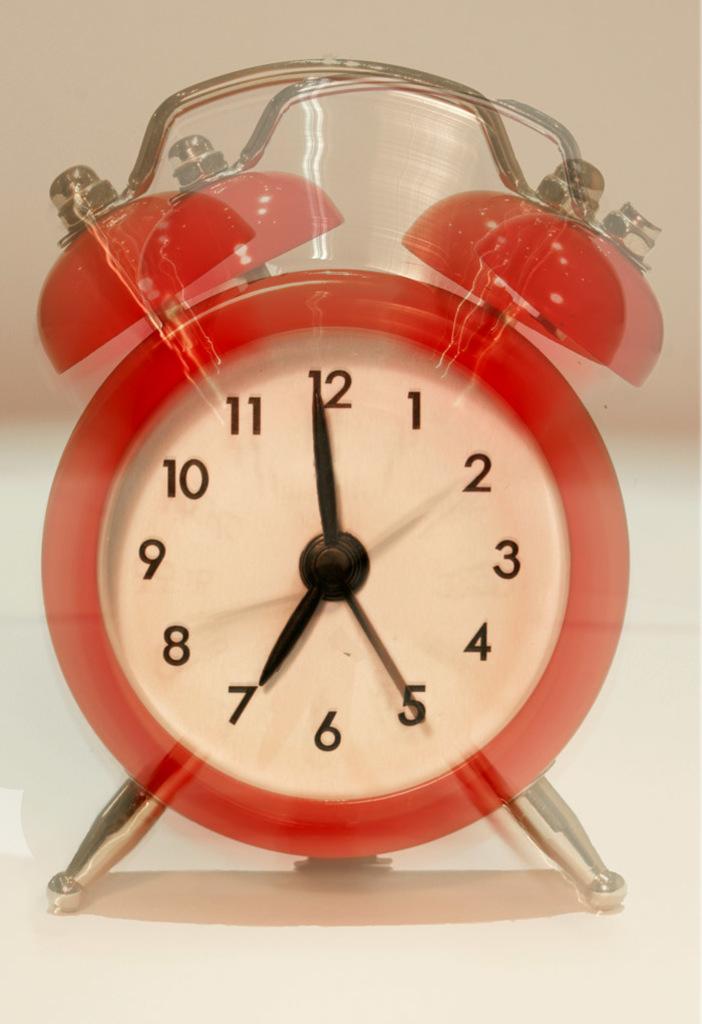What number does the big hand point to on the clock?
Make the answer very short. 12. What number is the thinnest hand pointing to?
Keep it short and to the point. 5. 